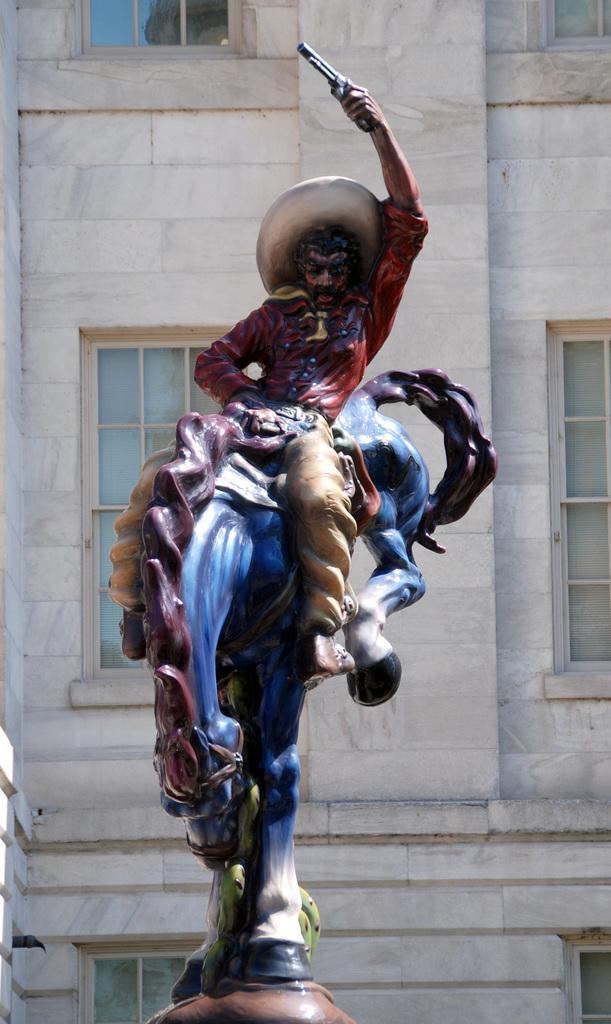How would you summarize this image in a sentence or two? This picture is of the outside. In the center of the picture we can see the Sculpture of a Horse and a Man. There is a Man who is wearing a hat and holding a gun in his hand and sitting on the Horse. In the background there is a building and we can see the windows of that building. 